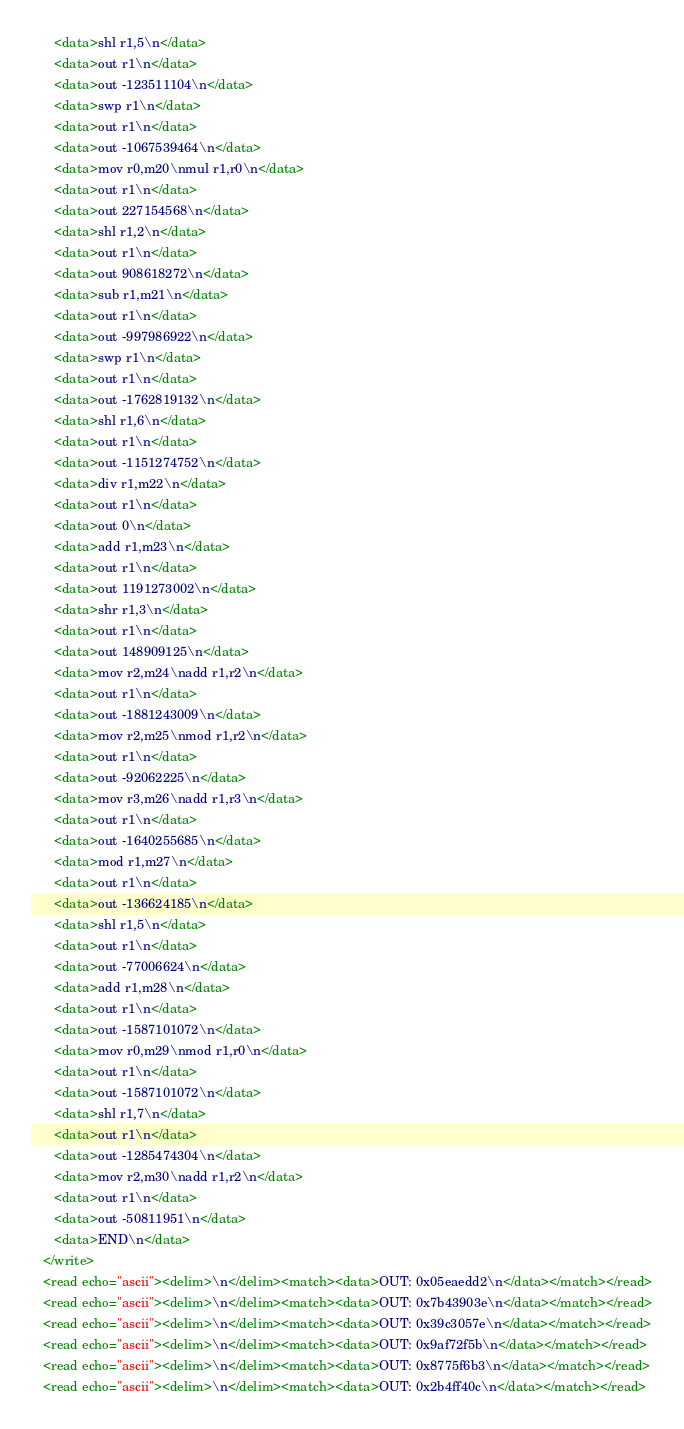Convert code to text. <code><loc_0><loc_0><loc_500><loc_500><_XML_>      <data>shl r1,5\n</data>
      <data>out r1\n</data>
      <data>out -123511104\n</data>
      <data>swp r1\n</data>
      <data>out r1\n</data>
      <data>out -1067539464\n</data>
      <data>mov r0,m20\nmul r1,r0\n</data>
      <data>out r1\n</data>
      <data>out 227154568\n</data>
      <data>shl r1,2\n</data>
      <data>out r1\n</data>
      <data>out 908618272\n</data>
      <data>sub r1,m21\n</data>
      <data>out r1\n</data>
      <data>out -997986922\n</data>
      <data>swp r1\n</data>
      <data>out r1\n</data>
      <data>out -1762819132\n</data>
      <data>shl r1,6\n</data>
      <data>out r1\n</data>
      <data>out -1151274752\n</data>
      <data>div r1,m22\n</data>
      <data>out r1\n</data>
      <data>out 0\n</data>
      <data>add r1,m23\n</data>
      <data>out r1\n</data>
      <data>out 1191273002\n</data>
      <data>shr r1,3\n</data>
      <data>out r1\n</data>
      <data>out 148909125\n</data>
      <data>mov r2,m24\nadd r1,r2\n</data>
      <data>out r1\n</data>
      <data>out -1881243009\n</data>
      <data>mov r2,m25\nmod r1,r2\n</data>
      <data>out r1\n</data>
      <data>out -92062225\n</data>
      <data>mov r3,m26\nadd r1,r3\n</data>
      <data>out r1\n</data>
      <data>out -1640255685\n</data>
      <data>mod r1,m27\n</data>
      <data>out r1\n</data>
      <data>out -136624185\n</data>
      <data>shl r1,5\n</data>
      <data>out r1\n</data>
      <data>out -77006624\n</data>
      <data>add r1,m28\n</data>
      <data>out r1\n</data>
      <data>out -1587101072\n</data>
      <data>mov r0,m29\nmod r1,r0\n</data>
      <data>out r1\n</data>
      <data>out -1587101072\n</data>
      <data>shl r1,7\n</data>
      <data>out r1\n</data>
      <data>out -1285474304\n</data>
      <data>mov r2,m30\nadd r1,r2\n</data>
      <data>out r1\n</data>
      <data>out -50811951\n</data>
      <data>END\n</data>
   </write>
   <read echo="ascii"><delim>\n</delim><match><data>OUT: 0x05eaedd2\n</data></match></read>
   <read echo="ascii"><delim>\n</delim><match><data>OUT: 0x7b43903e\n</data></match></read>
   <read echo="ascii"><delim>\n</delim><match><data>OUT: 0x39c3057e\n</data></match></read>
   <read echo="ascii"><delim>\n</delim><match><data>OUT: 0x9af72f5b\n</data></match></read>
   <read echo="ascii"><delim>\n</delim><match><data>OUT: 0x8775f6b3\n</data></match></read>
   <read echo="ascii"><delim>\n</delim><match><data>OUT: 0x2b4ff40c\n</data></match></read></code> 